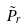Convert formula to latex. <formula><loc_0><loc_0><loc_500><loc_500>\tilde { P } _ { r }</formula> 